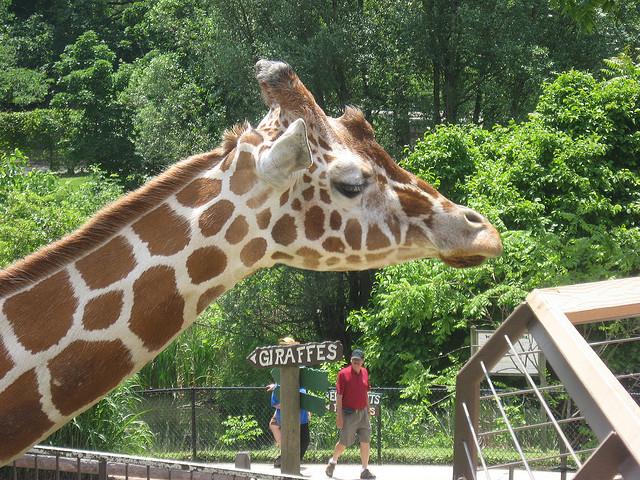Are the giraffe's eyes open?
Keep it brief. Yes. What does the sign beside the people say?
Give a very brief answer. Giraffes. Which way is the Giraffes sign pointing?
Concise answer only. Left. 